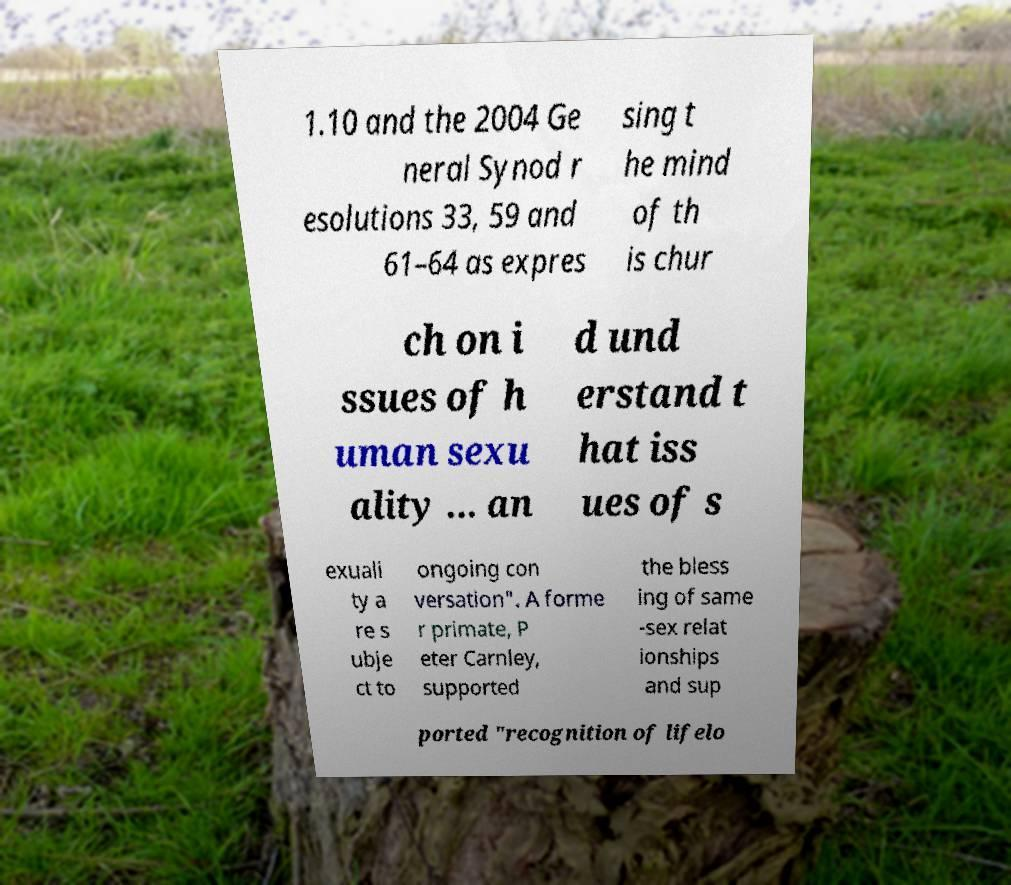I need the written content from this picture converted into text. Can you do that? 1.10 and the 2004 Ge neral Synod r esolutions 33, 59 and 61–64 as expres sing t he mind of th is chur ch on i ssues of h uman sexu ality ... an d und erstand t hat iss ues of s exuali ty a re s ubje ct to ongoing con versation". A forme r primate, P eter Carnley, supported the bless ing of same -sex relat ionships and sup ported "recognition of lifelo 